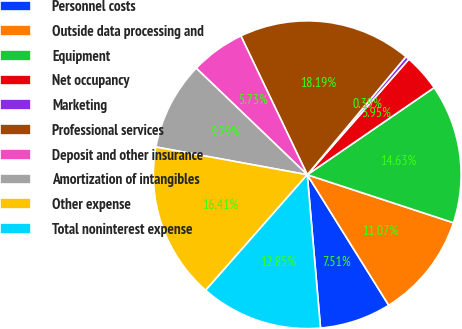<chart> <loc_0><loc_0><loc_500><loc_500><pie_chart><fcel>Personnel costs<fcel>Outside data processing and<fcel>Equipment<fcel>Net occupancy<fcel>Marketing<fcel>Professional services<fcel>Deposit and other insurance<fcel>Amortization of intangibles<fcel>Other expense<fcel>Total noninterest expense<nl><fcel>7.51%<fcel>11.07%<fcel>14.63%<fcel>3.95%<fcel>0.39%<fcel>18.19%<fcel>5.73%<fcel>9.29%<fcel>16.41%<fcel>12.85%<nl></chart> 